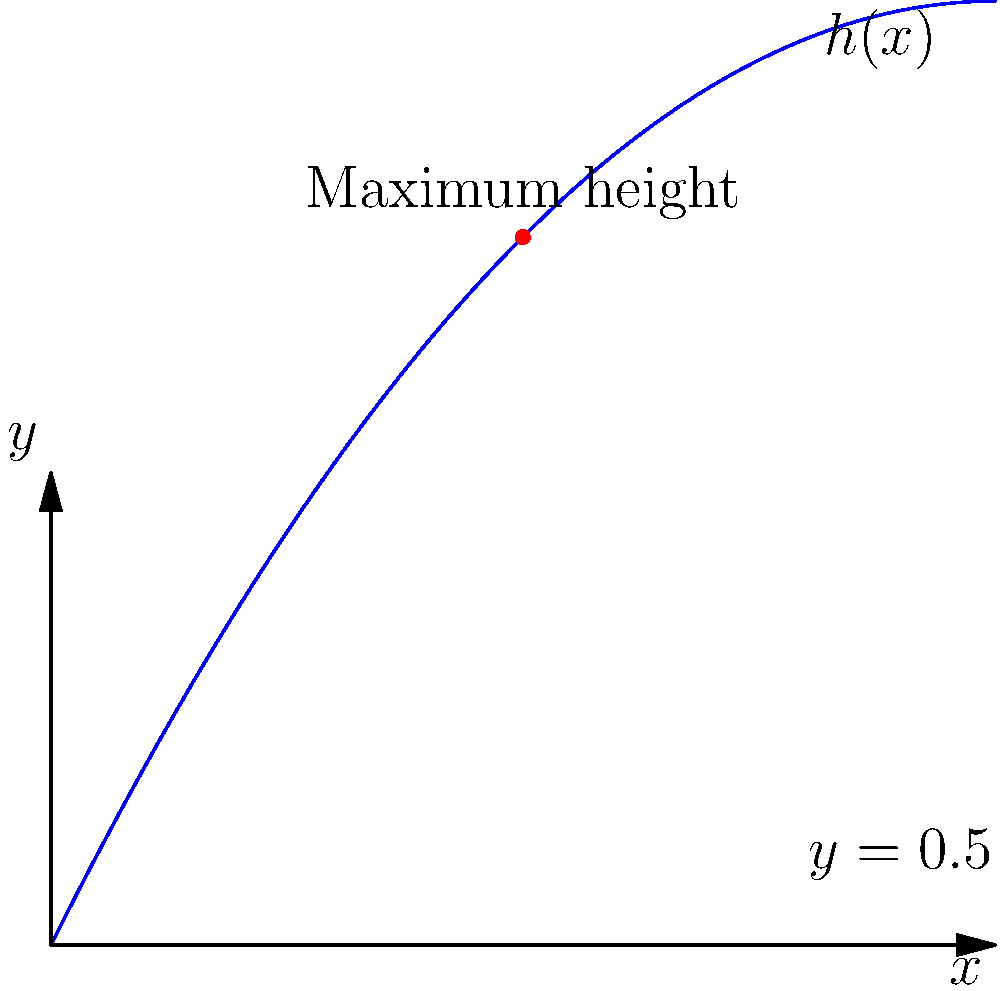As a precision stunt driver, you're planning a jump over a barrier of height 0.5 units. The trajectory of your stunt car can be modeled by the function $h(x) = -0.1x^2 + 2x$, where $x$ is the horizontal distance and $h(x)$ is the height. What is the maximum horizontal distance you can safely jump while clearing the barrier, and at what $x$ value does the car reach its maximum height? Let's approach this step-by-step:

1) First, we need to find where the car's trajectory intersects with the barrier height. This occurs when:

   $h(x) = 0.5$
   $-0.1x^2 + 2x = 0.5$

2) Rearranging this equation:
   $0.1x^2 - 2x + 0.5 = 0$

3) This is a quadratic equation. We can solve it using the quadratic formula:
   $x = \frac{-b \pm \sqrt{b^2 - 4ac}}{2a}$

   Where $a=0.1$, $b=-2$, and $c=0.5$

4) Plugging in these values:
   $x = \frac{2 \pm \sqrt{4 - 0.2}}{0.2} = \frac{2 \pm \sqrt{3.8}}{0.2}$

5) This gives us two solutions:
   $x_1 \approx 0.46$ and $x_2 \approx 9.54$

6) The larger value, 9.54, represents the maximum horizontal distance we can jump while clearing the barrier.

7) To find where the car reaches its maximum height, we need to find the vertex of the parabola. For a quadratic function $f(x) = ax^2 + bx + c$, the x-coordinate of the vertex is given by $x = -\frac{b}{2a}$.

8) In our case, $a=-0.1$ and $b=2$, so:
   $x = -\frac{2}{2(-0.1)} = 10$

Therefore, the car reaches its maximum height at $x = 10$.
Answer: Maximum jump distance: 9.54 units. Maximum height at $x = 10$. 